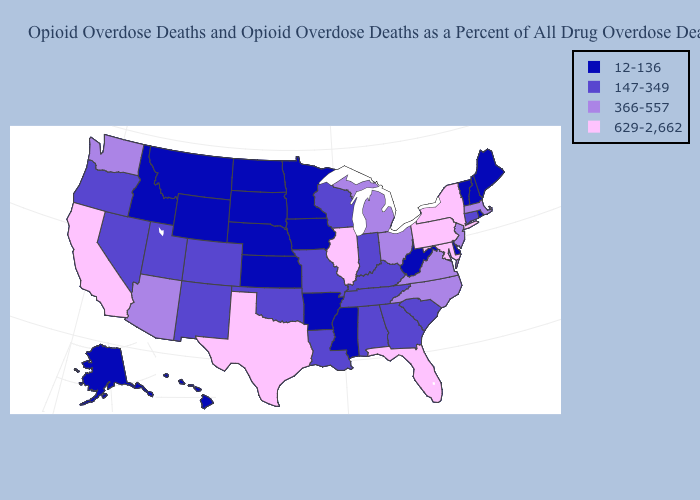Does Tennessee have the same value as Connecticut?
Quick response, please. Yes. Which states hav the highest value in the West?
Give a very brief answer. California. Name the states that have a value in the range 629-2,662?
Short answer required. California, Florida, Illinois, Maryland, New York, Pennsylvania, Texas. Name the states that have a value in the range 629-2,662?
Concise answer only. California, Florida, Illinois, Maryland, New York, Pennsylvania, Texas. Name the states that have a value in the range 12-136?
Quick response, please. Alaska, Arkansas, Delaware, Hawaii, Idaho, Iowa, Kansas, Maine, Minnesota, Mississippi, Montana, Nebraska, New Hampshire, North Dakota, Rhode Island, South Dakota, Vermont, West Virginia, Wyoming. Name the states that have a value in the range 366-557?
Concise answer only. Arizona, Massachusetts, Michigan, New Jersey, North Carolina, Ohio, Virginia, Washington. Name the states that have a value in the range 12-136?
Be succinct. Alaska, Arkansas, Delaware, Hawaii, Idaho, Iowa, Kansas, Maine, Minnesota, Mississippi, Montana, Nebraska, New Hampshire, North Dakota, Rhode Island, South Dakota, Vermont, West Virginia, Wyoming. Among the states that border Kentucky , does Illinois have the highest value?
Short answer required. Yes. Name the states that have a value in the range 629-2,662?
Concise answer only. California, Florida, Illinois, Maryland, New York, Pennsylvania, Texas. What is the value of South Dakota?
Concise answer only. 12-136. Which states have the lowest value in the Northeast?
Concise answer only. Maine, New Hampshire, Rhode Island, Vermont. Among the states that border Wyoming , which have the highest value?
Write a very short answer. Colorado, Utah. What is the value of New Mexico?
Write a very short answer. 147-349. Name the states that have a value in the range 366-557?
Give a very brief answer. Arizona, Massachusetts, Michigan, New Jersey, North Carolina, Ohio, Virginia, Washington. 